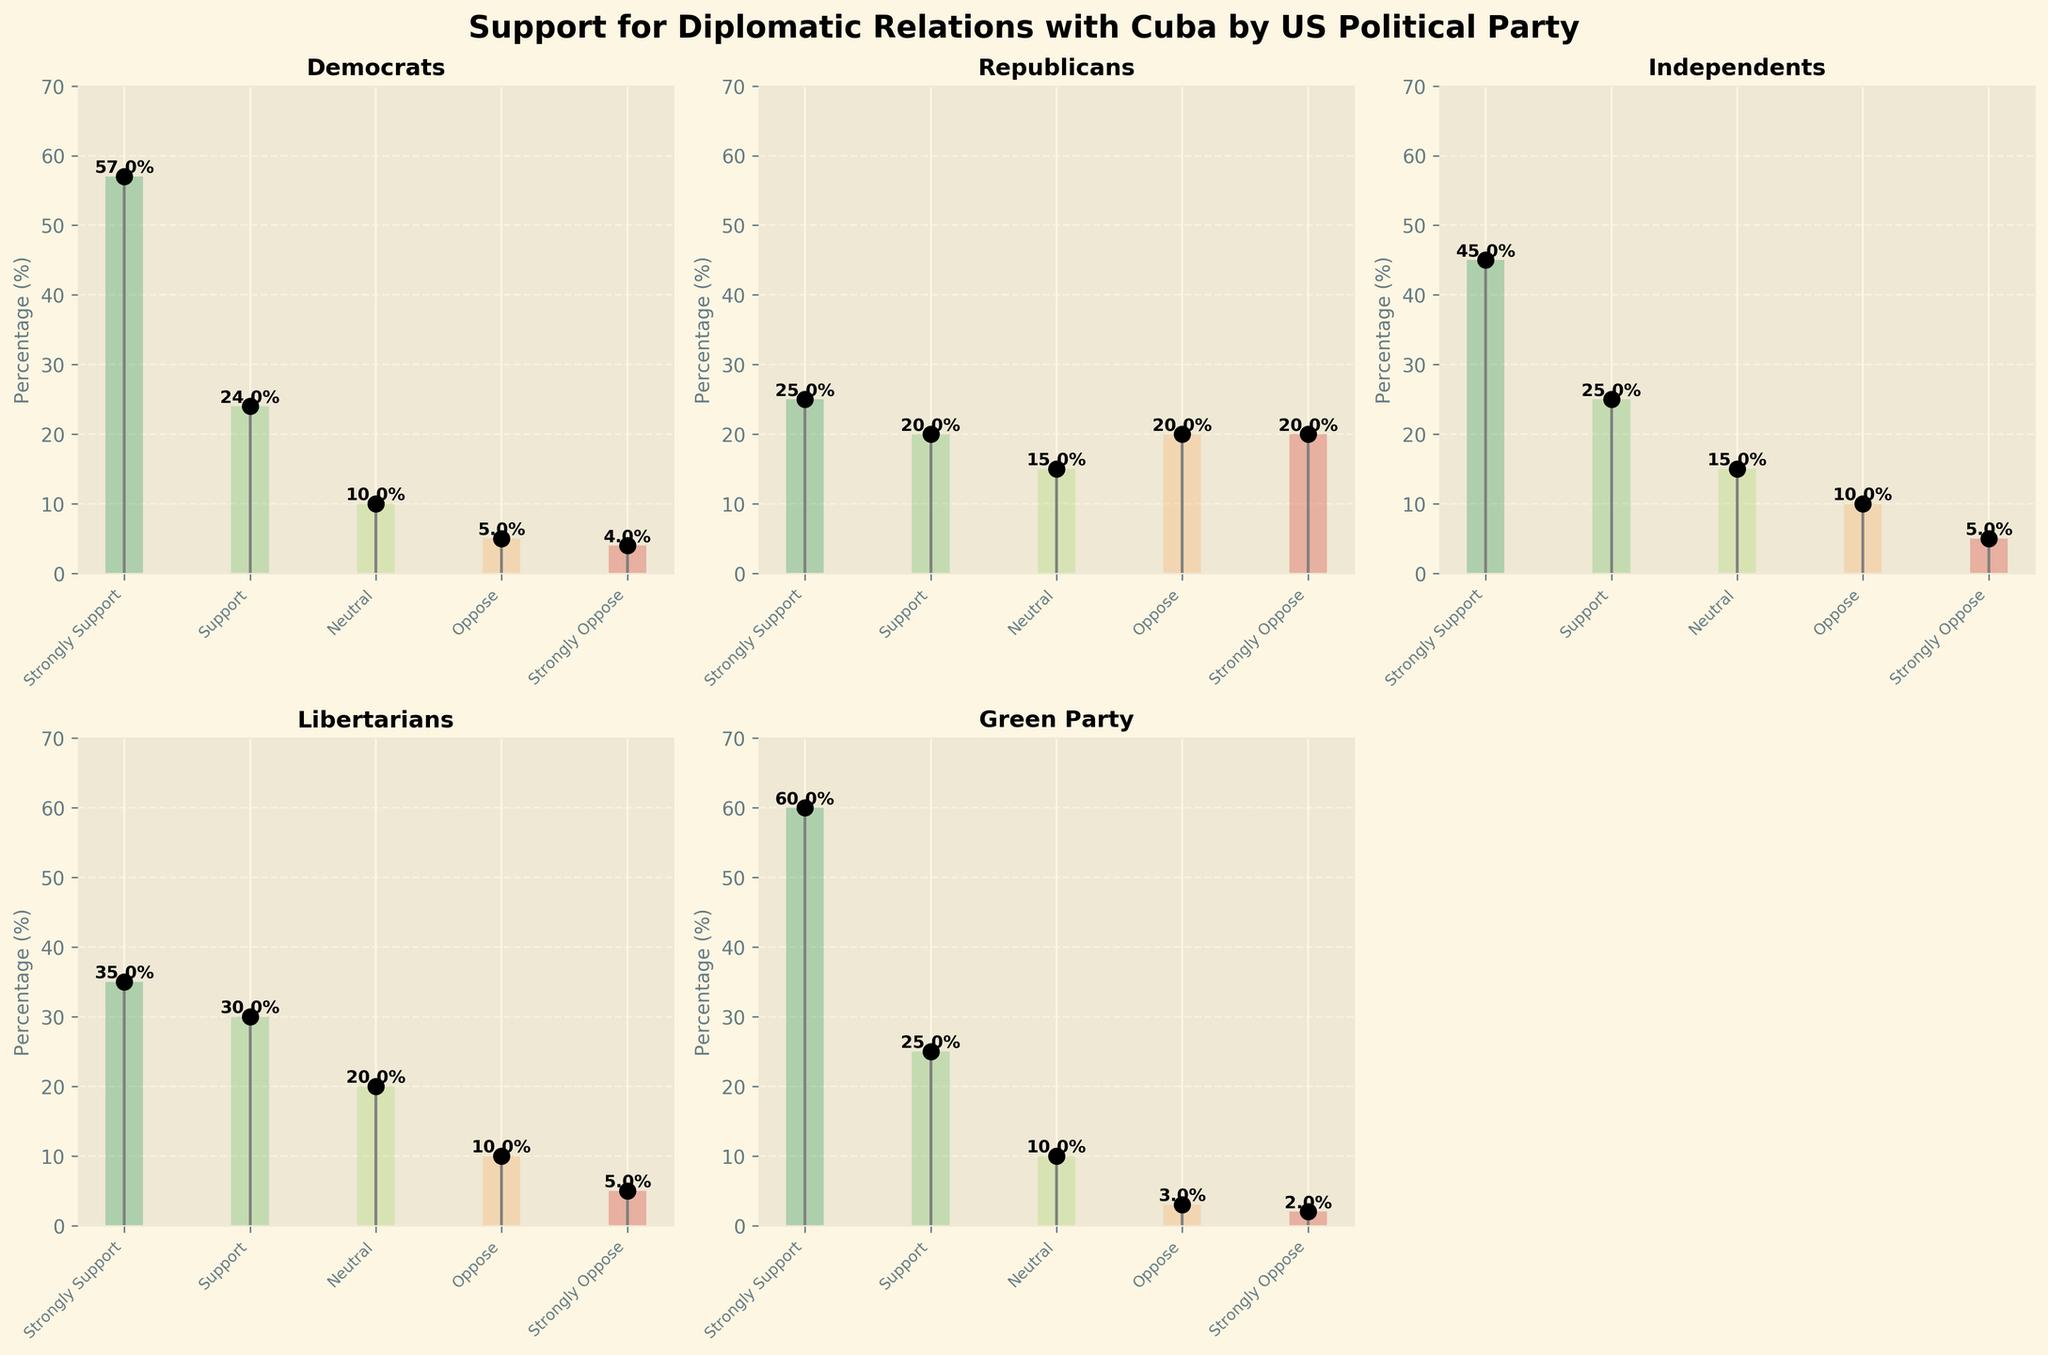What is the title of the figure? The title is usually displayed at the top of the figure. In this case, it is mentioned explicitly in the code under `fig.suptitle`.
Answer: Support for Diplomatic Relations with Cuba by US Political Party Which political party has the highest percentage of "Strongly Support"? To find this answer, look at the values of "Strongly Support" for each party. The highest value is for the Green Party at 60%.
Answer: Green Party What is the average percentage of "Support" across all political parties? Sum the "Support" percentages for all parties: 24 + 20 + 25 + 30 + 25 = 124. Then divide by the number of parties, which is 5. The average is 124 / 5 = 24.8.
Answer: 24.8% Which party has the smallest percentage of "Strongly Oppose"? Look at the "Strongly Oppose" percentages for each party. The smallest percentage is for the Green Party with 2%.
Answer: Green Party Is there any party where the sum of "Oppose" and "Strongly Oppose" percentages is more significant than those who "Support" and "Strongly Support"? Calculate the sums for "Oppose" + "Strongly Oppose" and "Support" + "Strongly Support" for each party:
- Democrats: 5 + 4 = 9 (Oppose), 57 + 24 = 81 (Support)
- Republicans: 20 + 20 = 40 (Oppose), 25 + 20 = 45 (Support)
- Independents: 10 + 5 = 15 (Oppose), 45 + 25 = 70 (Support)
- Libertarians: 10 + 5 = 15 (Oppose), 35 + 30 = 65 (Support)
- Green Party: 3 + 2 = 5 (Oppose), 60 + 25 = 85 (Support)
From this, we see no party has a greater sum of opposing percentages than supporting.
Answer: No For which political party is the percentage of "Neutral" exactly 10%? Look at the "Neutral" percentages for all parties. The Democrats, Independents, and Green Party each have 10%.
Answer: Democrats, Independents, Green Party Compare the percentage of "Oppose" in Democrats and Republicans. Which is greater? The Democrats have 5% "Oppose" and the Republicans have 20%. Thus, Republicans have a higher percentage of "Oppose".
Answer: Republicans 